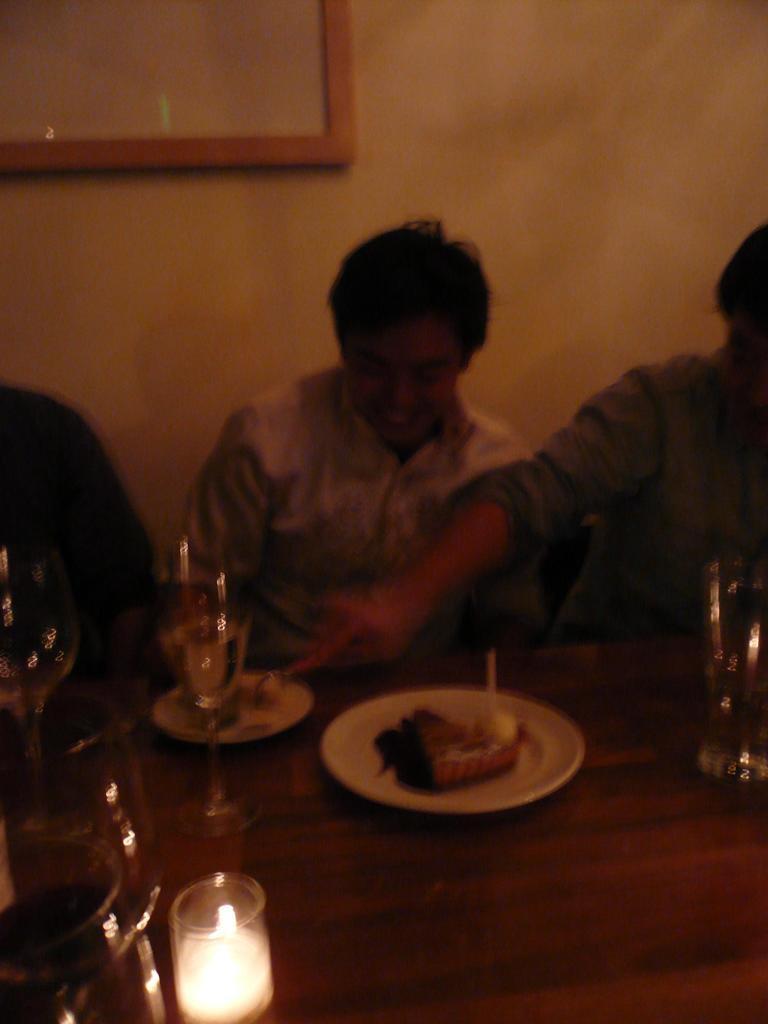Can you describe this image briefly? In this image, there are a few people. We can see a table with some objects like food items in plates, glasses. In the background, we can see the wall with an object. 